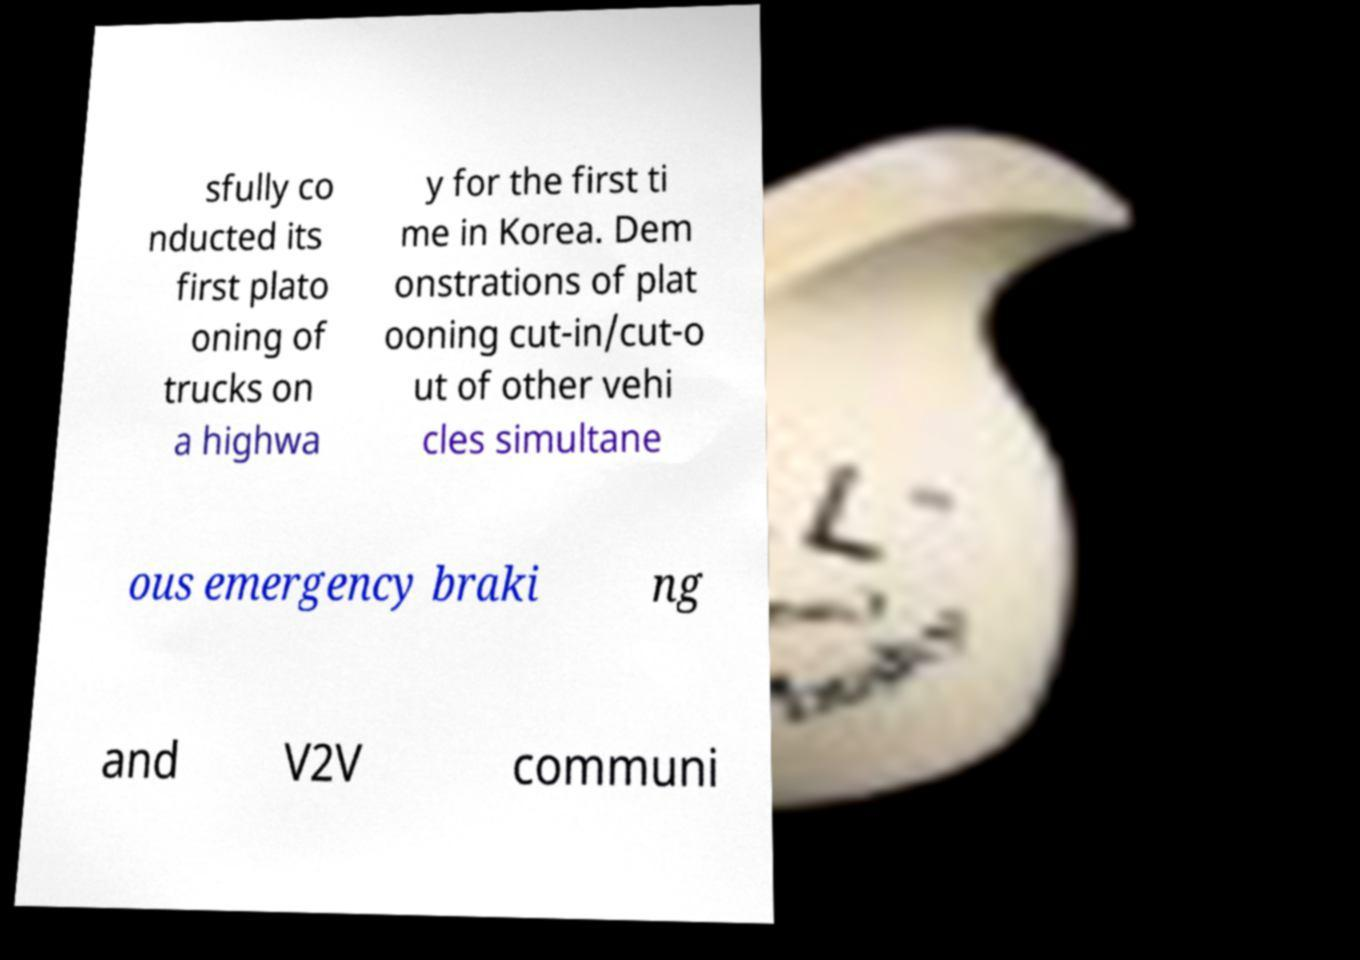I need the written content from this picture converted into text. Can you do that? sfully co nducted its first plato oning of trucks on a highwa y for the first ti me in Korea. Dem onstrations of plat ooning cut-in/cut-o ut of other vehi cles simultane ous emergency braki ng and V2V communi 